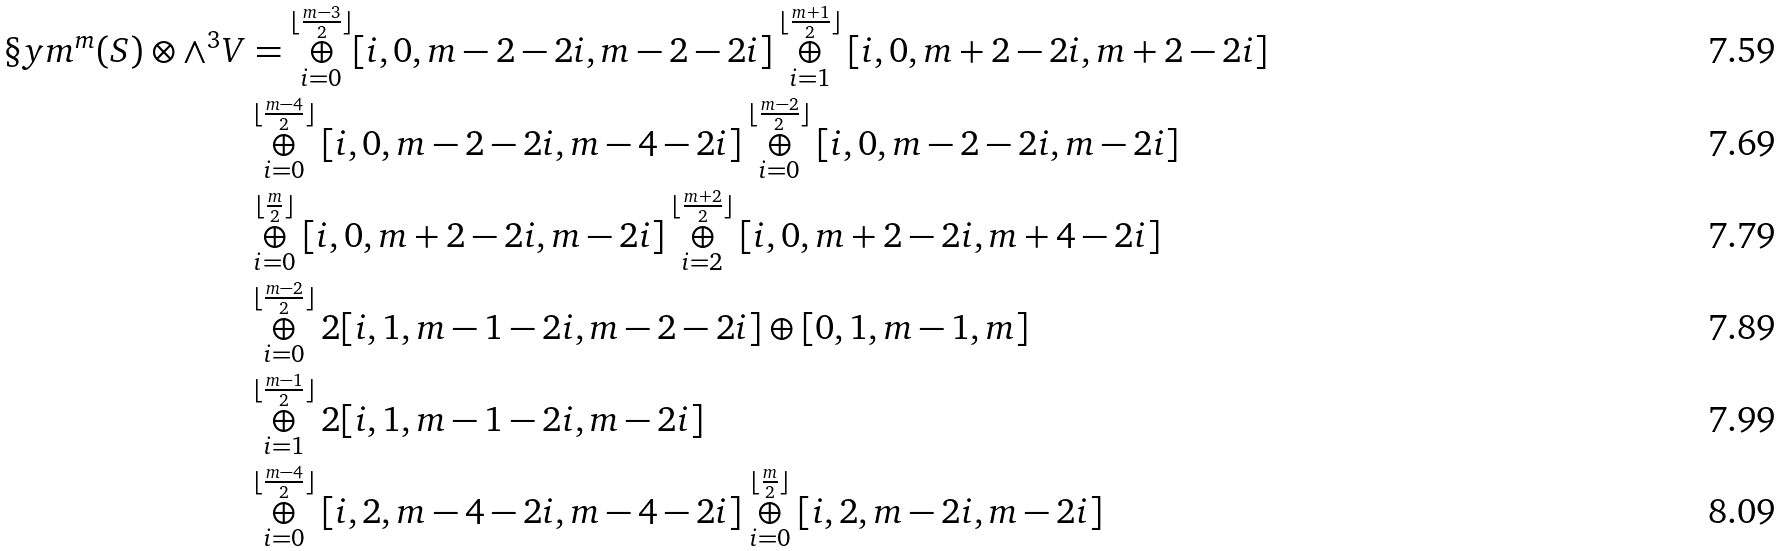Convert formula to latex. <formula><loc_0><loc_0><loc_500><loc_500>\S y m ^ { m } ( S ) \otimes \wedge ^ { 3 } V & = \overset { \lfloor \frac { m - 3 } { 2 } \rfloor } { \underset { i = 0 } { \oplus } } [ i , 0 , m - 2 - 2 i , m - 2 - 2 i ] \overset { \lfloor \frac { m + 1 } { 2 } \rfloor } { \underset { i = 1 } { \oplus } } [ i , 0 , m + 2 - 2 i , m + 2 - 2 i ] \\ & \overset { \lfloor \frac { m - 4 } { 2 } \rfloor } { \underset { i = 0 } { \oplus } } [ i , 0 , m - 2 - 2 i , m - 4 - 2 i ] \overset { \lfloor \frac { m - 2 } { 2 } \rfloor } { \underset { i = 0 } { \oplus } } [ i , 0 , m - 2 - 2 i , m - 2 i ] \\ & \overset { \lfloor \frac { m } { 2 } \rfloor } { \underset { i = 0 } { \oplus } } [ i , 0 , m + 2 - 2 i , m - 2 i ] \overset { \lfloor \frac { m + 2 } { 2 } \rfloor } { \underset { i = 2 } { \oplus } } [ i , 0 , m + 2 - 2 i , m + 4 - 2 i ] \\ & \overset { \lfloor \frac { m - 2 } { 2 } \rfloor } { \underset { i = 0 } { \oplus } } 2 [ i , 1 , m - 1 - 2 i , m - 2 - 2 i ] \oplus [ 0 , 1 , m - 1 , m ] \\ & \overset { \lfloor \frac { m - 1 } { 2 } \rfloor } { \underset { i = 1 } { \oplus } } 2 [ i , 1 , m - 1 - 2 i , m - 2 i ] \\ & \overset { \lfloor \frac { m - 4 } { 2 } \rfloor } { \underset { i = 0 } { \oplus } } [ i , 2 , m - 4 - 2 i , m - 4 - 2 i ] \overset { \lfloor \frac { m } { 2 } \rfloor } { \underset { i = 0 } { \oplus } } [ i , 2 , m - 2 i , m - 2 i ]</formula> 